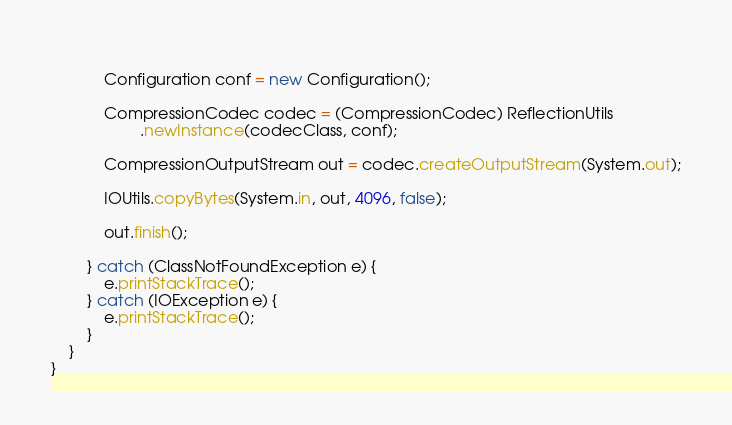<code> <loc_0><loc_0><loc_500><loc_500><_Java_>			
			Configuration conf = new Configuration();
			
			CompressionCodec codec = (CompressionCodec) ReflectionUtils
					.newInstance(codecClass, conf);
			
			CompressionOutputStream out = codec.createOutputStream(System.out);
			
			IOUtils.copyBytes(System.in, out, 4096, false);
			
			out.finish();
			
		} catch (ClassNotFoundException e) {
			e.printStackTrace();
		} catch (IOException e) {
			e.printStackTrace();
		}
	}
}
</code> 